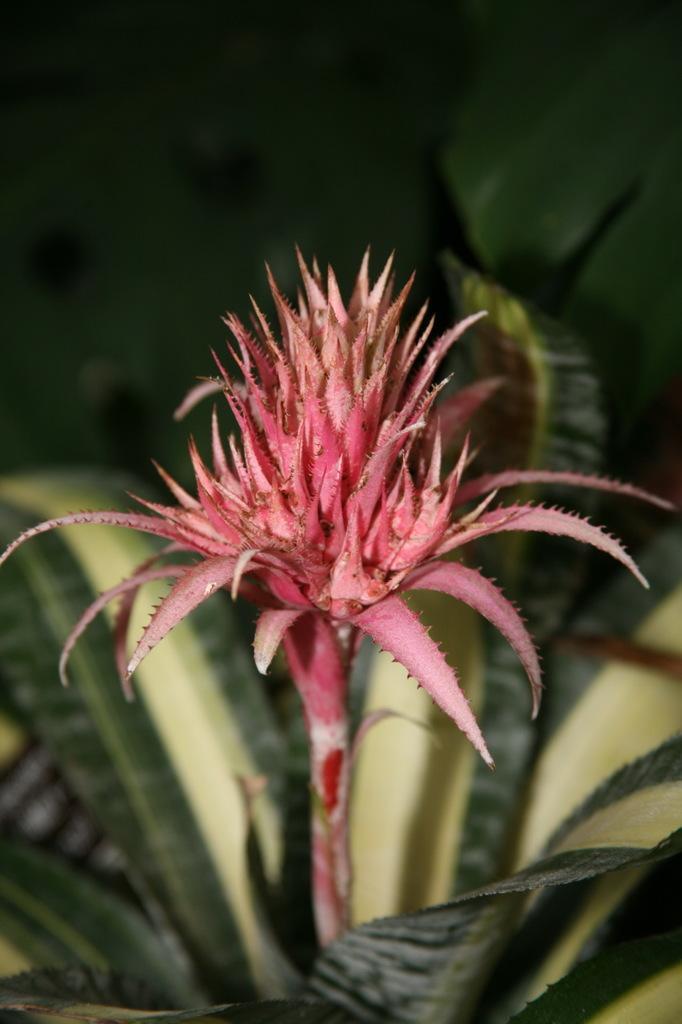How would you summarize this image in a sentence or two? In the center of the image there is a flower. At the bottom there are leaves. 